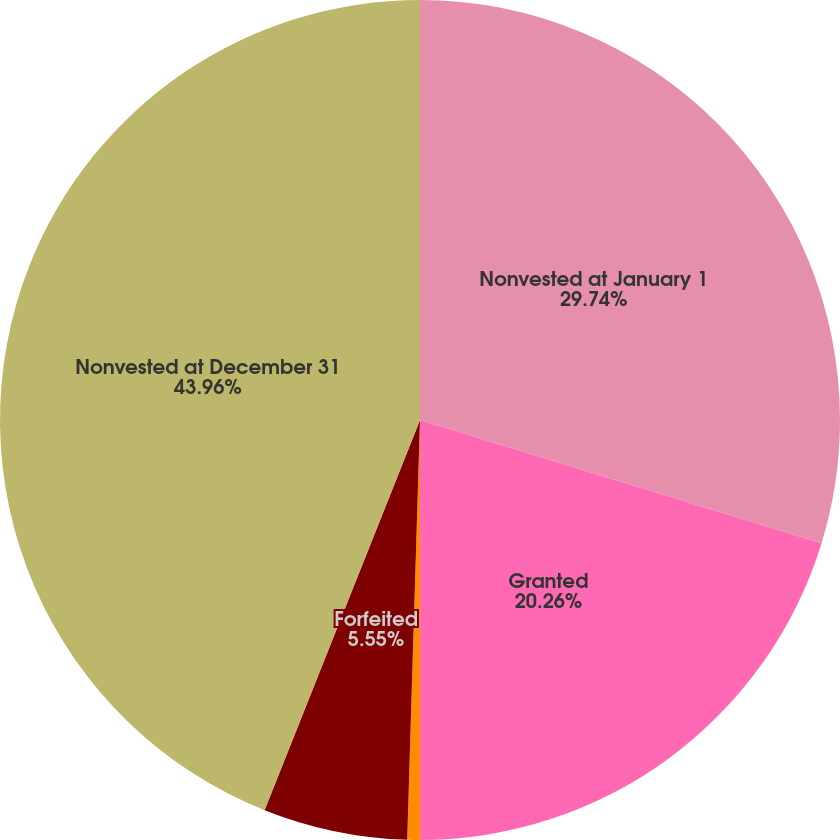<chart> <loc_0><loc_0><loc_500><loc_500><pie_chart><fcel>Nonvested at January 1<fcel>Granted<fcel>Vested<fcel>Forfeited<fcel>Nonvested at December 31<nl><fcel>29.74%<fcel>20.26%<fcel>0.49%<fcel>5.55%<fcel>43.97%<nl></chart> 